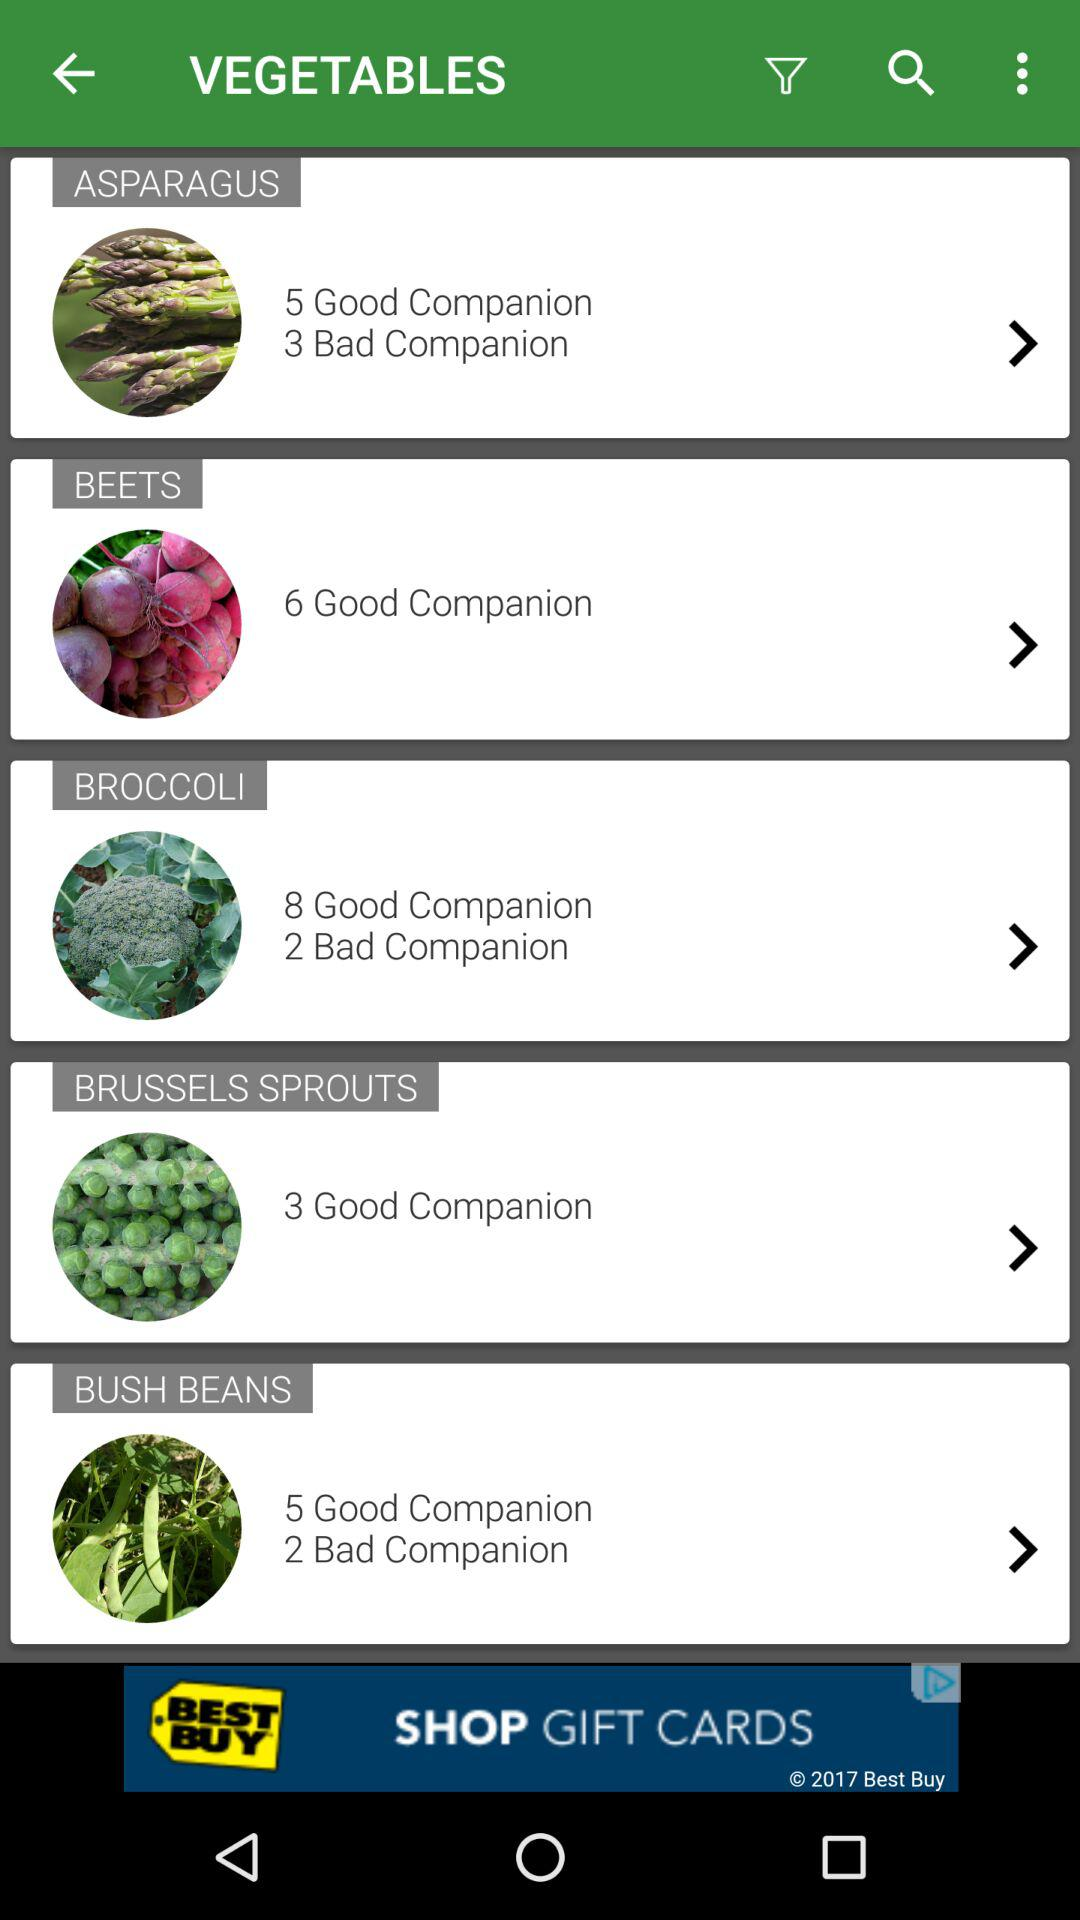How many good companions are there for "BUSH BEANS"? There are 5 good companions. 